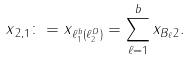<formula> <loc_0><loc_0><loc_500><loc_500>\| x \| _ { 2 , 1 } \colon = \| x \| _ { \ell _ { 1 } ^ { b } ( \ell _ { 2 } ^ { D } ) } = \sum _ { \ell = 1 } ^ { b } \| x _ { B _ { \ell } } \| _ { 2 } .</formula> 